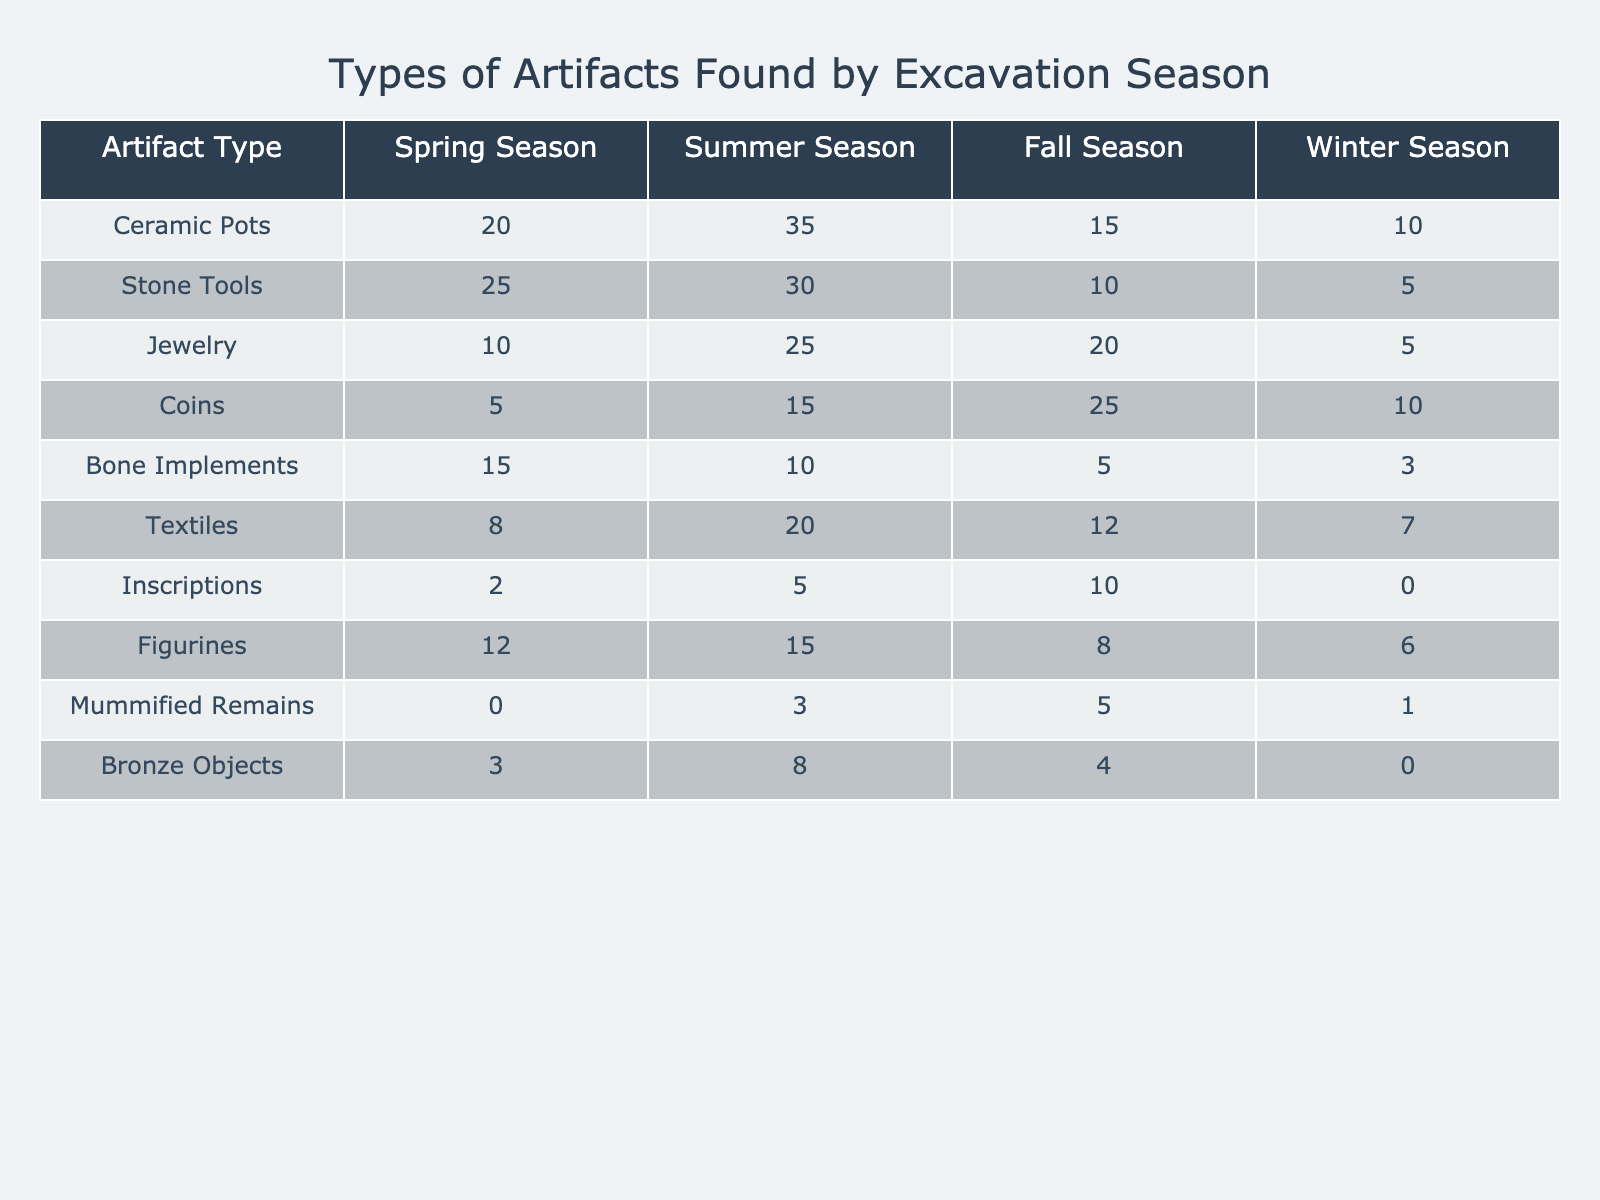What is the total number of Ceramic Pots found during all seasons? To find the total number of Ceramic Pots, we need to add the values for each season: Spring (20) + Summer (35) + Fall (15) + Winter (10) = 20 + 35 + 15 + 10 = 80
Answer: 80 Which season had the highest number of Jewelry artifacts found? By looking at the Jewelry column, we see that the Summer season had 25 artifacts, Fall had 20, Spring had 10, and Winter had 5. The highest value is 25 in the Summer season.
Answer: Summer Is it true that more Stone Tools were found in Spring than in Winter? Comparing the values for Spring (25) and Winter (5) in the Stone Tools row shows that Spring has a higher number. Therefore, the statement is true.
Answer: Yes What is the difference in the number of Coins found between Fall and Spring? To find the difference, we subtract the number of Coins found in Spring (5) from the number found in Fall (25): 25 - 5 = 20.
Answer: 20 What is the average number of Figurines found across all seasons? We calculate the average by adding the total number of Figurines across all seasons: Spring (12) + Summer (15) + Fall (8) + Winter (6) = 12 + 15 + 8 + 6 = 41. Then we divide by the number of seasons (4): 41 / 4 = 10.25.
Answer: 10.25 In which season are the most Bone Implements found? Looking at the Bone Implements row: Spring has 15, Summer has 10, Fall has 5, and Winter has 3. Spring has the highest number at 15.
Answer: Spring Are there any Copper Objects found in the excavation? Referring to the table, there is no data for Copper Objects. Therefore, the answer to whether any Copper Objects were found is no.
Answer: No What is the total number of artifacts found in the Winter season? We sum the number of artifacts found in the Winter season across all types: Ceramic Pots (10) + Stone Tools (5) + Jewelry (5) + Coins (10) + Bone Implements (3) + Textiles (7) + Inscriptions (0) + Figurines (6) + Mummified Remains (1) + Bronze Objects (0). This adds up to: 10 + 5 + 5 + 10 + 3 + 7 + 0 + 6 + 1 + 0 = 47.
Answer: 47 Which type of artifact had the lowest number found in the Summer season? In the Summer season, the values are: Ceramic Pots (35), Stone Tools (30), Jewelry (25), Coins (15), Bone Implements (10), Textiles (20), Inscriptions (5), Figurines (15), Mummified Remains (3), and Bronze Objects (8). The lowest value is 3 for Mummified Remains.
Answer: Mummified Remains 